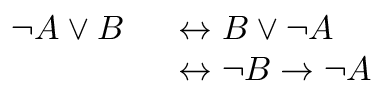<formula> <loc_0><loc_0><loc_500><loc_500>\begin{array} { r l } { \neg A \lor B \, } & \, \leftrightarrow B \lor \neg A } \\ { \, } & \, \leftrightarrow \neg B \to \neg A } \end{array}</formula> 